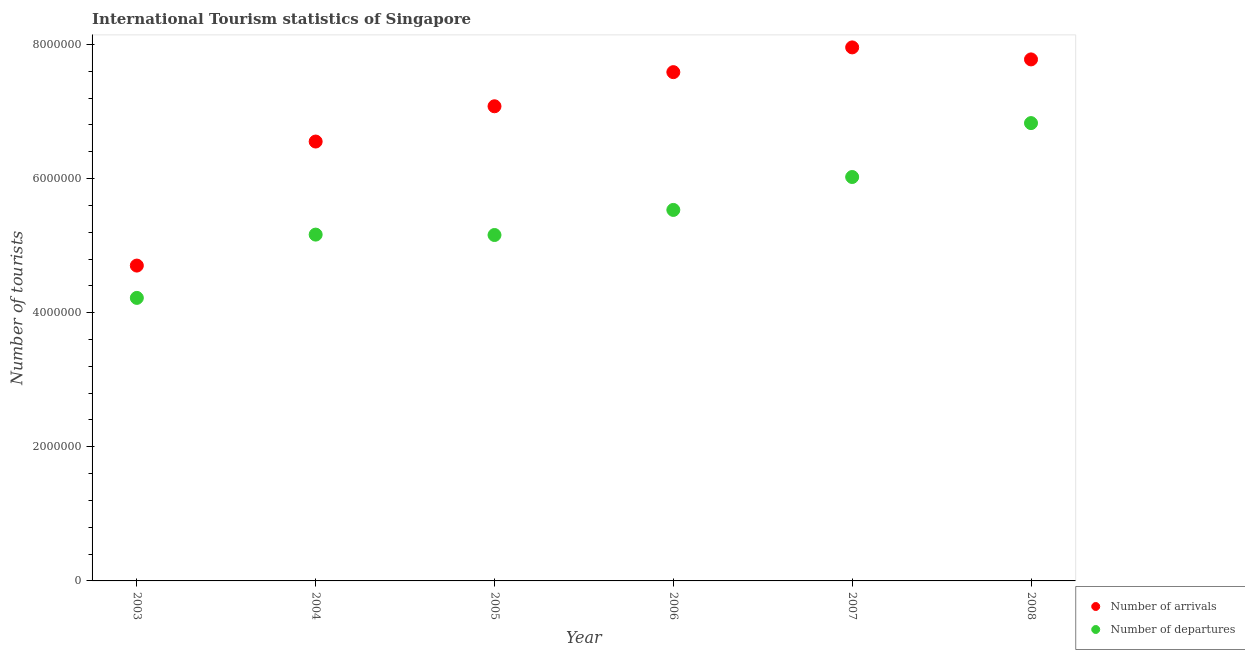What is the number of tourist arrivals in 2006?
Your response must be concise. 7.59e+06. Across all years, what is the maximum number of tourist arrivals?
Your response must be concise. 7.96e+06. Across all years, what is the minimum number of tourist arrivals?
Your answer should be very brief. 4.70e+06. What is the total number of tourist arrivals in the graph?
Your response must be concise. 4.17e+07. What is the difference between the number of tourist arrivals in 2004 and that in 2007?
Keep it short and to the point. -1.40e+06. What is the difference between the number of tourist arrivals in 2006 and the number of tourist departures in 2004?
Your answer should be very brief. 2.42e+06. What is the average number of tourist arrivals per year?
Offer a terse response. 6.94e+06. In the year 2004, what is the difference between the number of tourist departures and number of tourist arrivals?
Keep it short and to the point. -1.39e+06. What is the ratio of the number of tourist arrivals in 2006 to that in 2008?
Offer a very short reply. 0.98. Is the difference between the number of tourist arrivals in 2003 and 2007 greater than the difference between the number of tourist departures in 2003 and 2007?
Offer a terse response. No. What is the difference between the highest and the second highest number of tourist arrivals?
Your answer should be compact. 1.79e+05. What is the difference between the highest and the lowest number of tourist arrivals?
Keep it short and to the point. 3.25e+06. In how many years, is the number of tourist departures greater than the average number of tourist departures taken over all years?
Your response must be concise. 3. Does the number of tourist arrivals monotonically increase over the years?
Make the answer very short. No. Is the number of tourist arrivals strictly less than the number of tourist departures over the years?
Your answer should be very brief. No. How many years are there in the graph?
Keep it short and to the point. 6. What is the difference between two consecutive major ticks on the Y-axis?
Your response must be concise. 2.00e+06. Does the graph contain grids?
Your response must be concise. No. How are the legend labels stacked?
Offer a terse response. Vertical. What is the title of the graph?
Provide a short and direct response. International Tourism statistics of Singapore. Does "Secondary education" appear as one of the legend labels in the graph?
Ensure brevity in your answer.  No. What is the label or title of the X-axis?
Ensure brevity in your answer.  Year. What is the label or title of the Y-axis?
Offer a very short reply. Number of tourists. What is the Number of tourists in Number of arrivals in 2003?
Your answer should be very brief. 4.70e+06. What is the Number of tourists in Number of departures in 2003?
Provide a succinct answer. 4.22e+06. What is the Number of tourists in Number of arrivals in 2004?
Ensure brevity in your answer.  6.55e+06. What is the Number of tourists in Number of departures in 2004?
Offer a terse response. 5.16e+06. What is the Number of tourists of Number of arrivals in 2005?
Make the answer very short. 7.08e+06. What is the Number of tourists of Number of departures in 2005?
Provide a succinct answer. 5.16e+06. What is the Number of tourists of Number of arrivals in 2006?
Keep it short and to the point. 7.59e+06. What is the Number of tourists of Number of departures in 2006?
Provide a short and direct response. 5.53e+06. What is the Number of tourists in Number of arrivals in 2007?
Provide a succinct answer. 7.96e+06. What is the Number of tourists in Number of departures in 2007?
Ensure brevity in your answer.  6.02e+06. What is the Number of tourists of Number of arrivals in 2008?
Your answer should be compact. 7.78e+06. What is the Number of tourists of Number of departures in 2008?
Offer a very short reply. 6.83e+06. Across all years, what is the maximum Number of tourists of Number of arrivals?
Your response must be concise. 7.96e+06. Across all years, what is the maximum Number of tourists of Number of departures?
Your response must be concise. 6.83e+06. Across all years, what is the minimum Number of tourists in Number of arrivals?
Your answer should be very brief. 4.70e+06. Across all years, what is the minimum Number of tourists of Number of departures?
Give a very brief answer. 4.22e+06. What is the total Number of tourists of Number of arrivals in the graph?
Provide a short and direct response. 4.17e+07. What is the total Number of tourists in Number of departures in the graph?
Make the answer very short. 3.29e+07. What is the difference between the Number of tourists in Number of arrivals in 2003 and that in 2004?
Provide a succinct answer. -1.85e+06. What is the difference between the Number of tourists in Number of departures in 2003 and that in 2004?
Ensure brevity in your answer.  -9.44e+05. What is the difference between the Number of tourists in Number of arrivals in 2003 and that in 2005?
Make the answer very short. -2.38e+06. What is the difference between the Number of tourists of Number of departures in 2003 and that in 2005?
Your answer should be compact. -9.38e+05. What is the difference between the Number of tourists in Number of arrivals in 2003 and that in 2006?
Make the answer very short. -2.88e+06. What is the difference between the Number of tourists of Number of departures in 2003 and that in 2006?
Give a very brief answer. -1.31e+06. What is the difference between the Number of tourists of Number of arrivals in 2003 and that in 2007?
Offer a very short reply. -3.25e+06. What is the difference between the Number of tourists of Number of departures in 2003 and that in 2007?
Provide a succinct answer. -1.80e+06. What is the difference between the Number of tourists of Number of arrivals in 2003 and that in 2008?
Make the answer very short. -3.08e+06. What is the difference between the Number of tourists of Number of departures in 2003 and that in 2008?
Give a very brief answer. -2.61e+06. What is the difference between the Number of tourists in Number of arrivals in 2004 and that in 2005?
Offer a terse response. -5.26e+05. What is the difference between the Number of tourists of Number of departures in 2004 and that in 2005?
Provide a succinct answer. 6000. What is the difference between the Number of tourists of Number of arrivals in 2004 and that in 2006?
Provide a short and direct response. -1.04e+06. What is the difference between the Number of tourists in Number of departures in 2004 and that in 2006?
Provide a succinct answer. -3.68e+05. What is the difference between the Number of tourists of Number of arrivals in 2004 and that in 2007?
Keep it short and to the point. -1.40e+06. What is the difference between the Number of tourists of Number of departures in 2004 and that in 2007?
Your answer should be very brief. -8.59e+05. What is the difference between the Number of tourists of Number of arrivals in 2004 and that in 2008?
Offer a terse response. -1.22e+06. What is the difference between the Number of tourists in Number of departures in 2004 and that in 2008?
Ensure brevity in your answer.  -1.66e+06. What is the difference between the Number of tourists in Number of arrivals in 2005 and that in 2006?
Your response must be concise. -5.09e+05. What is the difference between the Number of tourists in Number of departures in 2005 and that in 2006?
Ensure brevity in your answer.  -3.74e+05. What is the difference between the Number of tourists in Number of arrivals in 2005 and that in 2007?
Offer a very short reply. -8.78e+05. What is the difference between the Number of tourists in Number of departures in 2005 and that in 2007?
Give a very brief answer. -8.65e+05. What is the difference between the Number of tourists of Number of arrivals in 2005 and that in 2008?
Your answer should be very brief. -6.99e+05. What is the difference between the Number of tourists in Number of departures in 2005 and that in 2008?
Offer a terse response. -1.67e+06. What is the difference between the Number of tourists of Number of arrivals in 2006 and that in 2007?
Provide a short and direct response. -3.69e+05. What is the difference between the Number of tourists of Number of departures in 2006 and that in 2007?
Make the answer very short. -4.91e+05. What is the difference between the Number of tourists of Number of departures in 2006 and that in 2008?
Your response must be concise. -1.30e+06. What is the difference between the Number of tourists of Number of arrivals in 2007 and that in 2008?
Give a very brief answer. 1.79e+05. What is the difference between the Number of tourists in Number of departures in 2007 and that in 2008?
Offer a terse response. -8.04e+05. What is the difference between the Number of tourists in Number of arrivals in 2003 and the Number of tourists in Number of departures in 2004?
Keep it short and to the point. -4.62e+05. What is the difference between the Number of tourists in Number of arrivals in 2003 and the Number of tourists in Number of departures in 2005?
Your answer should be compact. -4.56e+05. What is the difference between the Number of tourists of Number of arrivals in 2003 and the Number of tourists of Number of departures in 2006?
Your answer should be very brief. -8.30e+05. What is the difference between the Number of tourists of Number of arrivals in 2003 and the Number of tourists of Number of departures in 2007?
Make the answer very short. -1.32e+06. What is the difference between the Number of tourists of Number of arrivals in 2003 and the Number of tourists of Number of departures in 2008?
Offer a terse response. -2.12e+06. What is the difference between the Number of tourists of Number of arrivals in 2004 and the Number of tourists of Number of departures in 2005?
Give a very brief answer. 1.39e+06. What is the difference between the Number of tourists in Number of arrivals in 2004 and the Number of tourists in Number of departures in 2006?
Your answer should be compact. 1.02e+06. What is the difference between the Number of tourists of Number of arrivals in 2004 and the Number of tourists of Number of departures in 2007?
Keep it short and to the point. 5.29e+05. What is the difference between the Number of tourists in Number of arrivals in 2004 and the Number of tourists in Number of departures in 2008?
Your response must be concise. -2.75e+05. What is the difference between the Number of tourists of Number of arrivals in 2005 and the Number of tourists of Number of departures in 2006?
Offer a very short reply. 1.55e+06. What is the difference between the Number of tourists of Number of arrivals in 2005 and the Number of tourists of Number of departures in 2007?
Your answer should be compact. 1.06e+06. What is the difference between the Number of tourists of Number of arrivals in 2005 and the Number of tourists of Number of departures in 2008?
Keep it short and to the point. 2.51e+05. What is the difference between the Number of tourists of Number of arrivals in 2006 and the Number of tourists of Number of departures in 2007?
Your response must be concise. 1.56e+06. What is the difference between the Number of tourists in Number of arrivals in 2006 and the Number of tourists in Number of departures in 2008?
Your response must be concise. 7.60e+05. What is the difference between the Number of tourists in Number of arrivals in 2007 and the Number of tourists in Number of departures in 2008?
Give a very brief answer. 1.13e+06. What is the average Number of tourists of Number of arrivals per year?
Keep it short and to the point. 6.94e+06. What is the average Number of tourists of Number of departures per year?
Provide a succinct answer. 5.49e+06. In the year 2003, what is the difference between the Number of tourists in Number of arrivals and Number of tourists in Number of departures?
Your answer should be compact. 4.82e+05. In the year 2004, what is the difference between the Number of tourists in Number of arrivals and Number of tourists in Number of departures?
Offer a very short reply. 1.39e+06. In the year 2005, what is the difference between the Number of tourists in Number of arrivals and Number of tourists in Number of departures?
Keep it short and to the point. 1.92e+06. In the year 2006, what is the difference between the Number of tourists of Number of arrivals and Number of tourists of Number of departures?
Ensure brevity in your answer.  2.06e+06. In the year 2007, what is the difference between the Number of tourists of Number of arrivals and Number of tourists of Number of departures?
Keep it short and to the point. 1.93e+06. In the year 2008, what is the difference between the Number of tourists in Number of arrivals and Number of tourists in Number of departures?
Keep it short and to the point. 9.50e+05. What is the ratio of the Number of tourists in Number of arrivals in 2003 to that in 2004?
Give a very brief answer. 0.72. What is the ratio of the Number of tourists of Number of departures in 2003 to that in 2004?
Keep it short and to the point. 0.82. What is the ratio of the Number of tourists in Number of arrivals in 2003 to that in 2005?
Provide a succinct answer. 0.66. What is the ratio of the Number of tourists in Number of departures in 2003 to that in 2005?
Your answer should be very brief. 0.82. What is the ratio of the Number of tourists of Number of arrivals in 2003 to that in 2006?
Provide a succinct answer. 0.62. What is the ratio of the Number of tourists in Number of departures in 2003 to that in 2006?
Your answer should be very brief. 0.76. What is the ratio of the Number of tourists in Number of arrivals in 2003 to that in 2007?
Your answer should be compact. 0.59. What is the ratio of the Number of tourists in Number of departures in 2003 to that in 2007?
Give a very brief answer. 0.7. What is the ratio of the Number of tourists in Number of arrivals in 2003 to that in 2008?
Ensure brevity in your answer.  0.6. What is the ratio of the Number of tourists of Number of departures in 2003 to that in 2008?
Your response must be concise. 0.62. What is the ratio of the Number of tourists in Number of arrivals in 2004 to that in 2005?
Offer a terse response. 0.93. What is the ratio of the Number of tourists of Number of departures in 2004 to that in 2005?
Give a very brief answer. 1. What is the ratio of the Number of tourists in Number of arrivals in 2004 to that in 2006?
Your answer should be very brief. 0.86. What is the ratio of the Number of tourists in Number of departures in 2004 to that in 2006?
Offer a very short reply. 0.93. What is the ratio of the Number of tourists of Number of arrivals in 2004 to that in 2007?
Your answer should be very brief. 0.82. What is the ratio of the Number of tourists in Number of departures in 2004 to that in 2007?
Give a very brief answer. 0.86. What is the ratio of the Number of tourists in Number of arrivals in 2004 to that in 2008?
Give a very brief answer. 0.84. What is the ratio of the Number of tourists in Number of departures in 2004 to that in 2008?
Ensure brevity in your answer.  0.76. What is the ratio of the Number of tourists of Number of arrivals in 2005 to that in 2006?
Your answer should be compact. 0.93. What is the ratio of the Number of tourists in Number of departures in 2005 to that in 2006?
Give a very brief answer. 0.93. What is the ratio of the Number of tourists of Number of arrivals in 2005 to that in 2007?
Provide a succinct answer. 0.89. What is the ratio of the Number of tourists in Number of departures in 2005 to that in 2007?
Your answer should be compact. 0.86. What is the ratio of the Number of tourists in Number of arrivals in 2005 to that in 2008?
Offer a very short reply. 0.91. What is the ratio of the Number of tourists of Number of departures in 2005 to that in 2008?
Keep it short and to the point. 0.76. What is the ratio of the Number of tourists of Number of arrivals in 2006 to that in 2007?
Your answer should be compact. 0.95. What is the ratio of the Number of tourists of Number of departures in 2006 to that in 2007?
Ensure brevity in your answer.  0.92. What is the ratio of the Number of tourists of Number of arrivals in 2006 to that in 2008?
Give a very brief answer. 0.98. What is the ratio of the Number of tourists in Number of departures in 2006 to that in 2008?
Keep it short and to the point. 0.81. What is the ratio of the Number of tourists in Number of arrivals in 2007 to that in 2008?
Your response must be concise. 1.02. What is the ratio of the Number of tourists in Number of departures in 2007 to that in 2008?
Provide a short and direct response. 0.88. What is the difference between the highest and the second highest Number of tourists in Number of arrivals?
Offer a terse response. 1.79e+05. What is the difference between the highest and the second highest Number of tourists of Number of departures?
Offer a terse response. 8.04e+05. What is the difference between the highest and the lowest Number of tourists of Number of arrivals?
Your answer should be very brief. 3.25e+06. What is the difference between the highest and the lowest Number of tourists in Number of departures?
Offer a very short reply. 2.61e+06. 